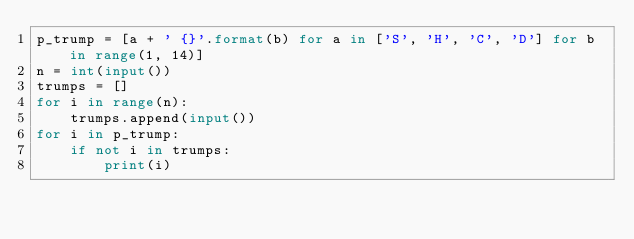<code> <loc_0><loc_0><loc_500><loc_500><_Python_>p_trump = [a + ' {}'.format(b) for a in ['S', 'H', 'C', 'D'] for b in range(1, 14)]
n = int(input())
trumps = []
for i in range(n):
    trumps.append(input())
for i in p_trump:
    if not i in trumps:
        print(i)

</code> 